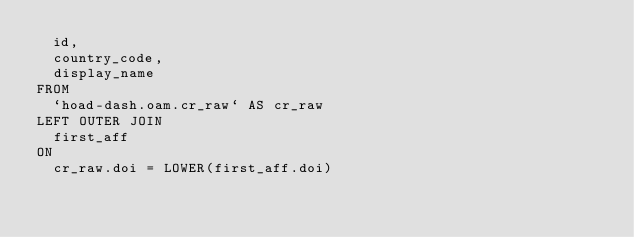<code> <loc_0><loc_0><loc_500><loc_500><_SQL_>  id,
  country_code,
  display_name
FROM
  `hoad-dash.oam.cr_raw` AS cr_raw
LEFT OUTER JOIN
  first_aff
ON
  cr_raw.doi = LOWER(first_aff.doi)
</code> 